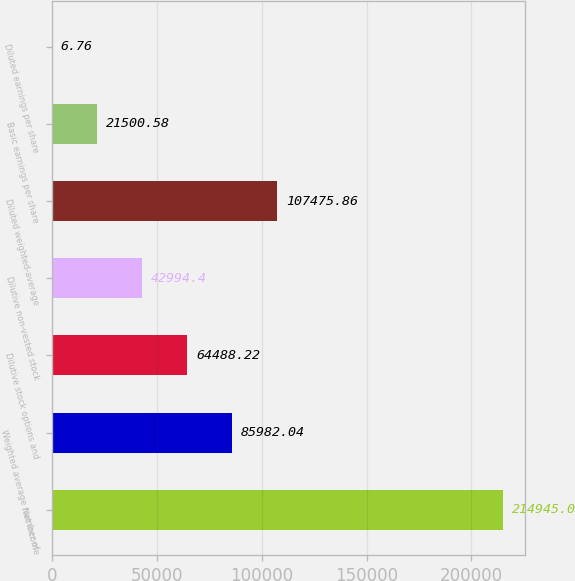Convert chart. <chart><loc_0><loc_0><loc_500><loc_500><bar_chart><fcel>Net income<fcel>Weighted average number of<fcel>Dilutive stock options and<fcel>Dilutive non-vested stock<fcel>Diluted weighted-average<fcel>Basic earnings per share<fcel>Diluted earnings per share<nl><fcel>214945<fcel>85982<fcel>64488.2<fcel>42994.4<fcel>107476<fcel>21500.6<fcel>6.76<nl></chart> 